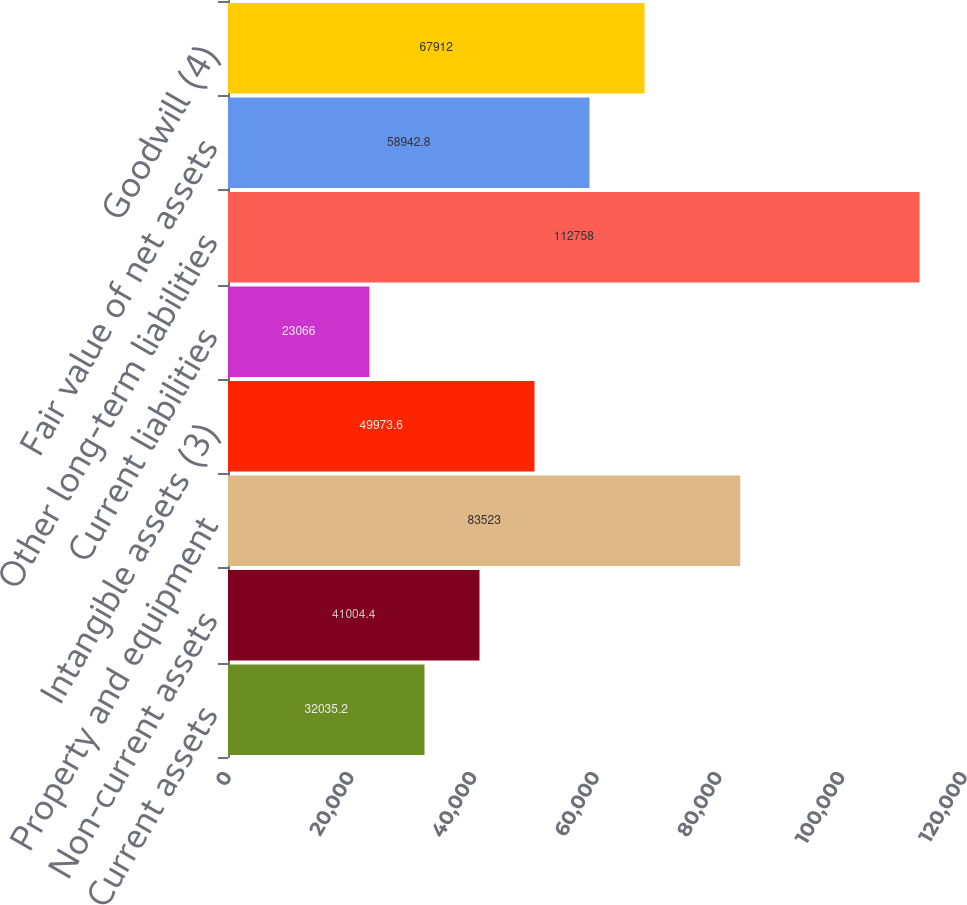Convert chart to OTSL. <chart><loc_0><loc_0><loc_500><loc_500><bar_chart><fcel>Current assets<fcel>Non-current assets<fcel>Property and equipment<fcel>Intangible assets (3)<fcel>Current liabilities<fcel>Other long-term liabilities<fcel>Fair value of net assets<fcel>Goodwill (4)<nl><fcel>32035.2<fcel>41004.4<fcel>83523<fcel>49973.6<fcel>23066<fcel>112758<fcel>58942.8<fcel>67912<nl></chart> 